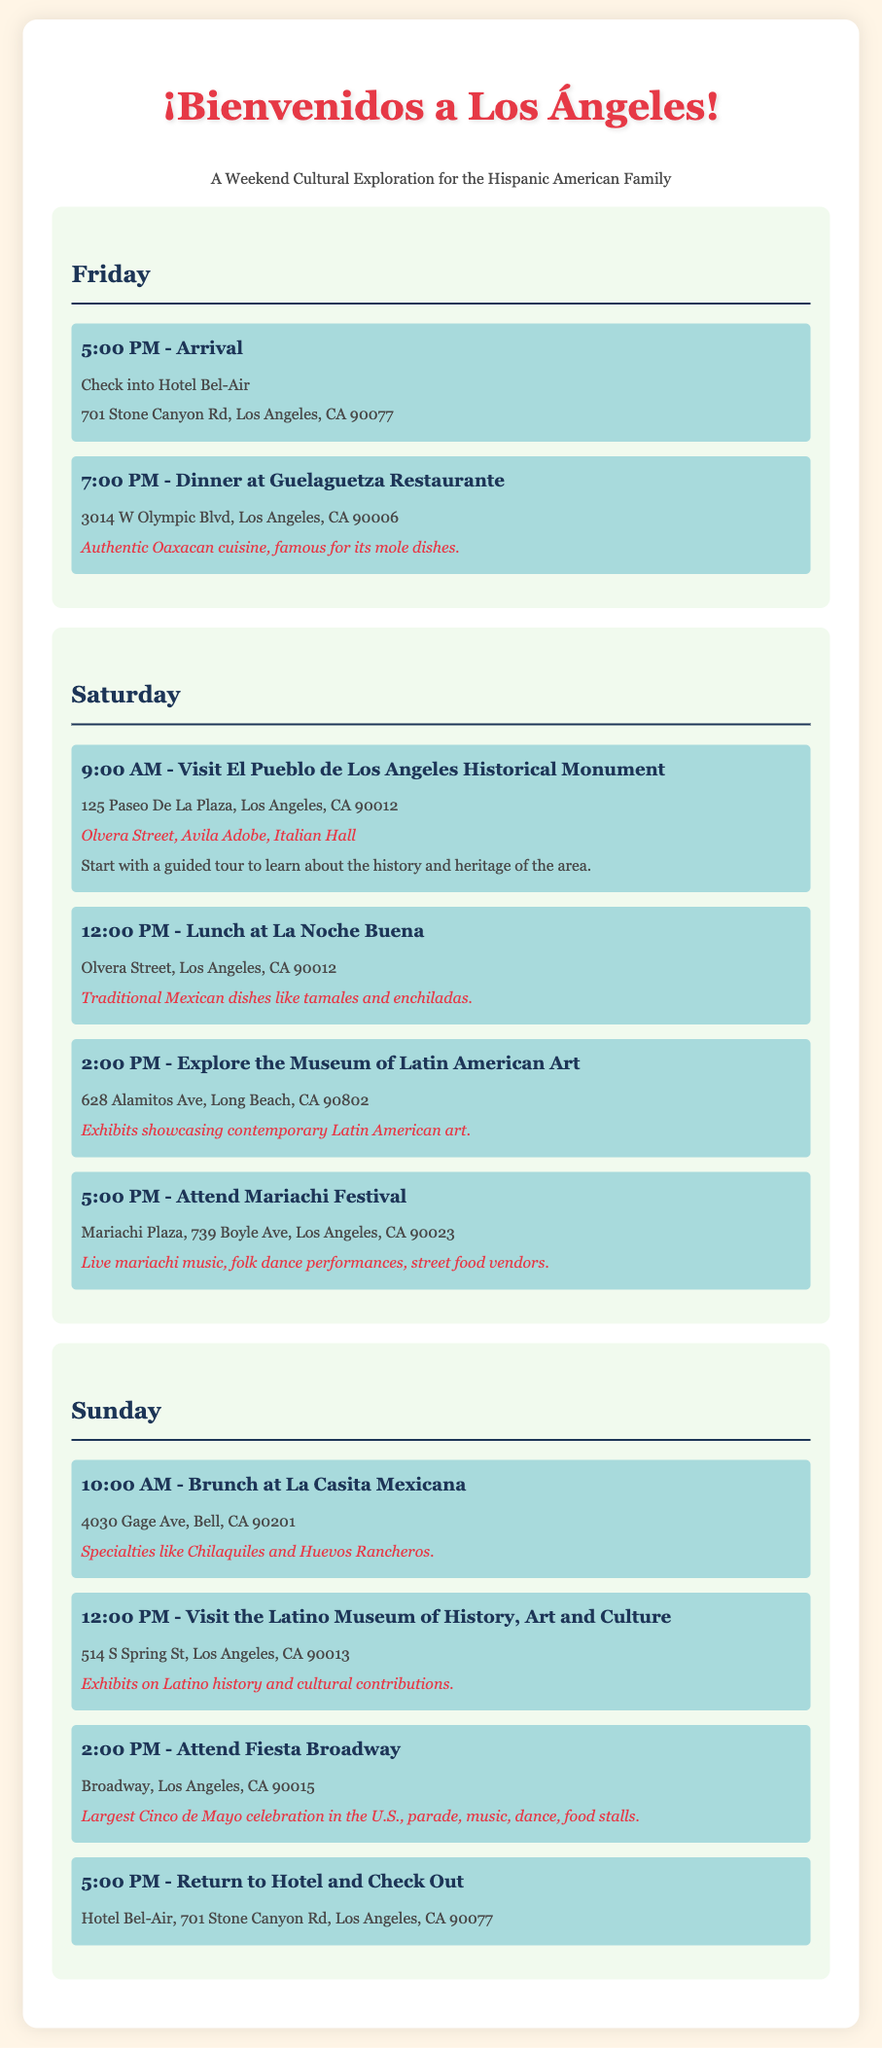What time is the arrival on Friday? The arrival time is specified in the itinerary under Friday activities at 5:00 PM.
Answer: 5:00 PM Where is the Mariachi Festival located? The location of the Mariachi Festival is mentioned in the Saturday activities section.
Answer: Mariachi Plaza, 739 Boyle Ave, Los Angeles, CA 90023 What is a specialty dish at La Casita Mexicana? The itinerary lists specialty dishes that are served at La Casita Mexicana during brunch on Sunday.
Answer: Chilaquiles How many activities are scheduled for Saturday? To determine the number of activities, we count the activities listed under Saturday, which total four.
Answer: 4 What is the address of the Latino Museum of History, Art and Culture? The address can be found under the Sunday activities in the itinerary.
Answer: 514 S Spring St, Los Angeles, CA 90013 Which meal is featured at Guelaguetza Restaurante? The menu highlight mentioned in the itinerary indicates the meal served at Guelaguetza Restaurante.
Answer: Authentic Oaxacan cuisine What event takes place at 2:00 PM on Sunday? The itinerary specifies the event scheduled at that time in the Sunday activities section.
Answer: Attend Fiesta Broadway What type of cuisine does La Noche Buena serve? The cuisine type is outlined in the activities section for lunch on Saturday.
Answer: Traditional Mexican dishes 